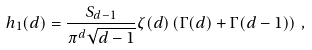<formula> <loc_0><loc_0><loc_500><loc_500>h _ { 1 } ( d ) = \frac { S _ { d - 1 } } { \pi ^ { d } \sqrt { d - 1 } } \zeta ( d ) \left ( \Gamma ( d ) + \Gamma ( d - 1 ) \right ) \, ,</formula> 